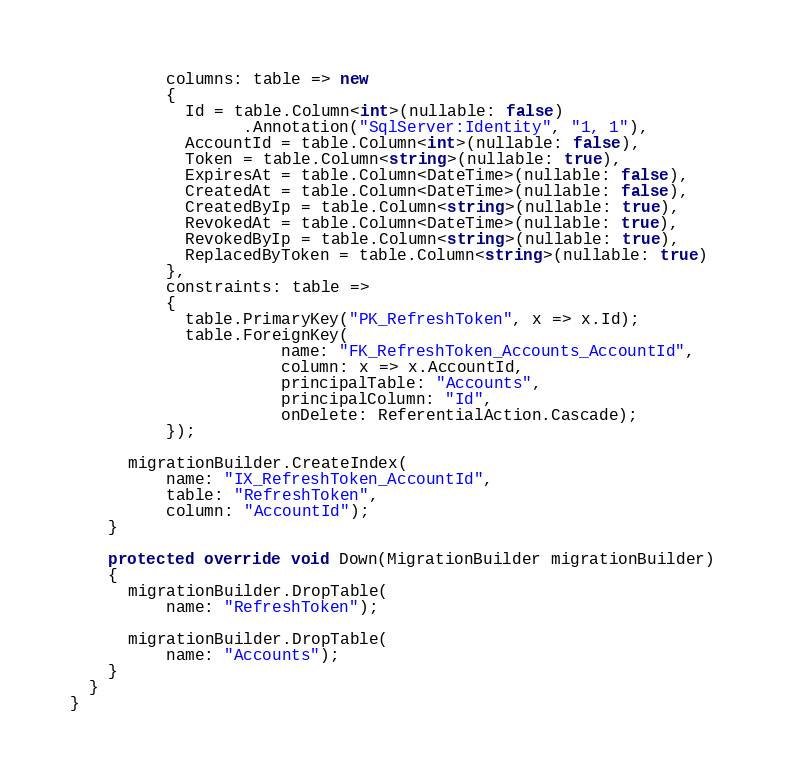<code> <loc_0><loc_0><loc_500><loc_500><_C#_>          columns: table => new
          {
            Id = table.Column<int>(nullable: false)
                  .Annotation("SqlServer:Identity", "1, 1"),
            AccountId = table.Column<int>(nullable: false),
            Token = table.Column<string>(nullable: true),
            ExpiresAt = table.Column<DateTime>(nullable: false),
            CreatedAt = table.Column<DateTime>(nullable: false),
            CreatedByIp = table.Column<string>(nullable: true),
            RevokedAt = table.Column<DateTime>(nullable: true),
            RevokedByIp = table.Column<string>(nullable: true),
            ReplacedByToken = table.Column<string>(nullable: true)
          },
          constraints: table =>
          {
            table.PrimaryKey("PK_RefreshToken", x => x.Id);
            table.ForeignKey(
                      name: "FK_RefreshToken_Accounts_AccountId",
                      column: x => x.AccountId,
                      principalTable: "Accounts",
                      principalColumn: "Id",
                      onDelete: ReferentialAction.Cascade);
          });

      migrationBuilder.CreateIndex(
          name: "IX_RefreshToken_AccountId",
          table: "RefreshToken",
          column: "AccountId");
    }

    protected override void Down(MigrationBuilder migrationBuilder)
    {
      migrationBuilder.DropTable(
          name: "RefreshToken");

      migrationBuilder.DropTable(
          name: "Accounts");
    }
  }
}
</code> 